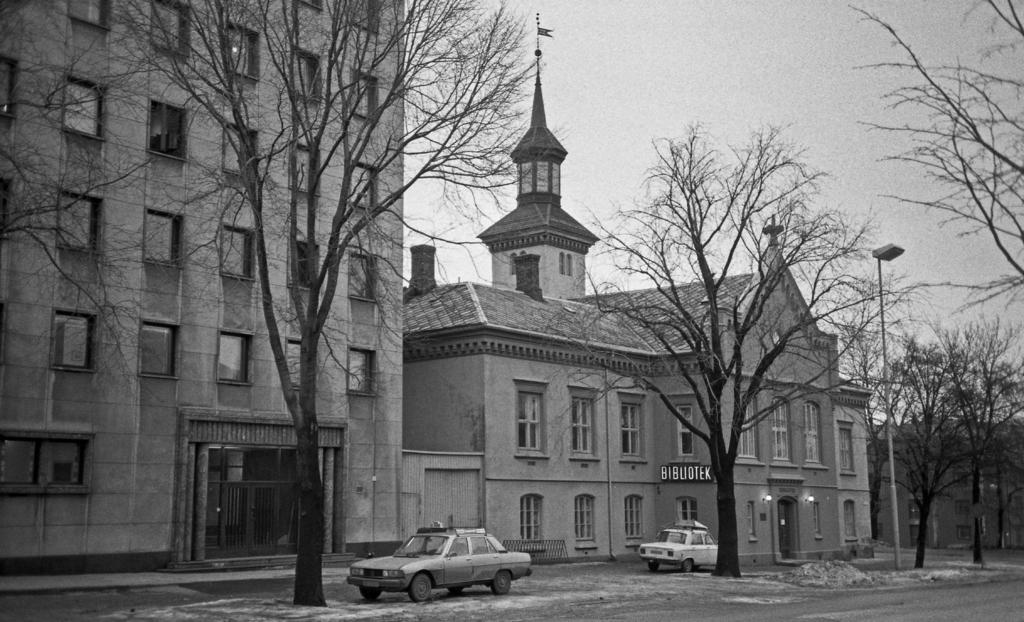What type of structures are visible in the image? There are buildings with windows in the image. What can be seen on the road at the bottom of the image? There are cars on the road at the bottom of the image. What type of vegetation is present in the front of the image? There are trees in the front of the image. What is visible at the top of the image? The sky is visible at the top of the image. What type of news can be seen on the road in the image? There is no news present in the image; it features buildings, cars, trees, and the sky. What type of quartz is visible in the image? There is no quartz present in the image. 